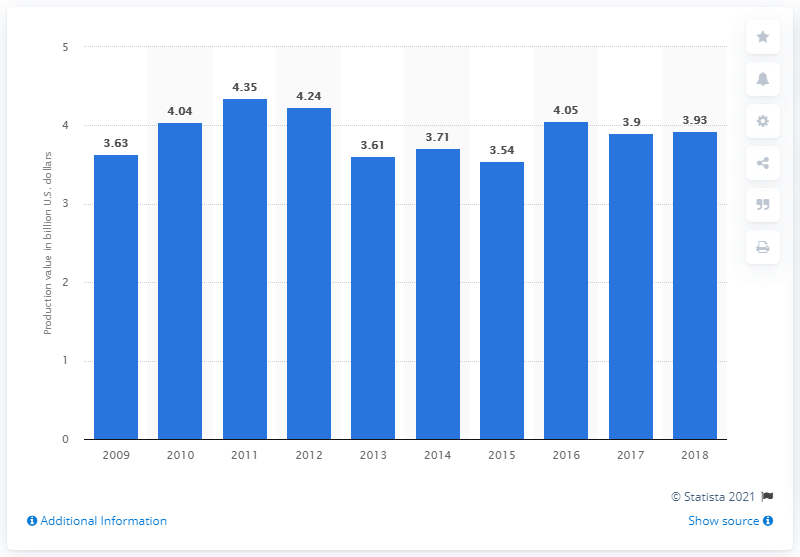Mention a couple of crucial points in this snapshot. The production value of aquaculture in Japan from the previous year was 3.93 billion U.S. dollars. Japanese aquaculture generated a production value of 3.93 billion US dollars in 2018. 